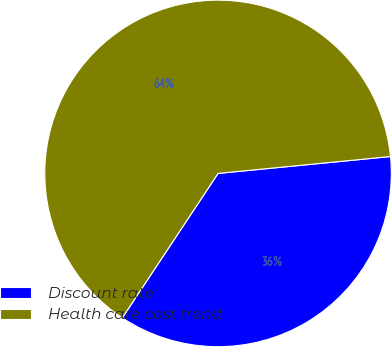Convert chart. <chart><loc_0><loc_0><loc_500><loc_500><pie_chart><fcel>Discount rate<fcel>Health care cost trend<nl><fcel>35.87%<fcel>64.13%<nl></chart> 